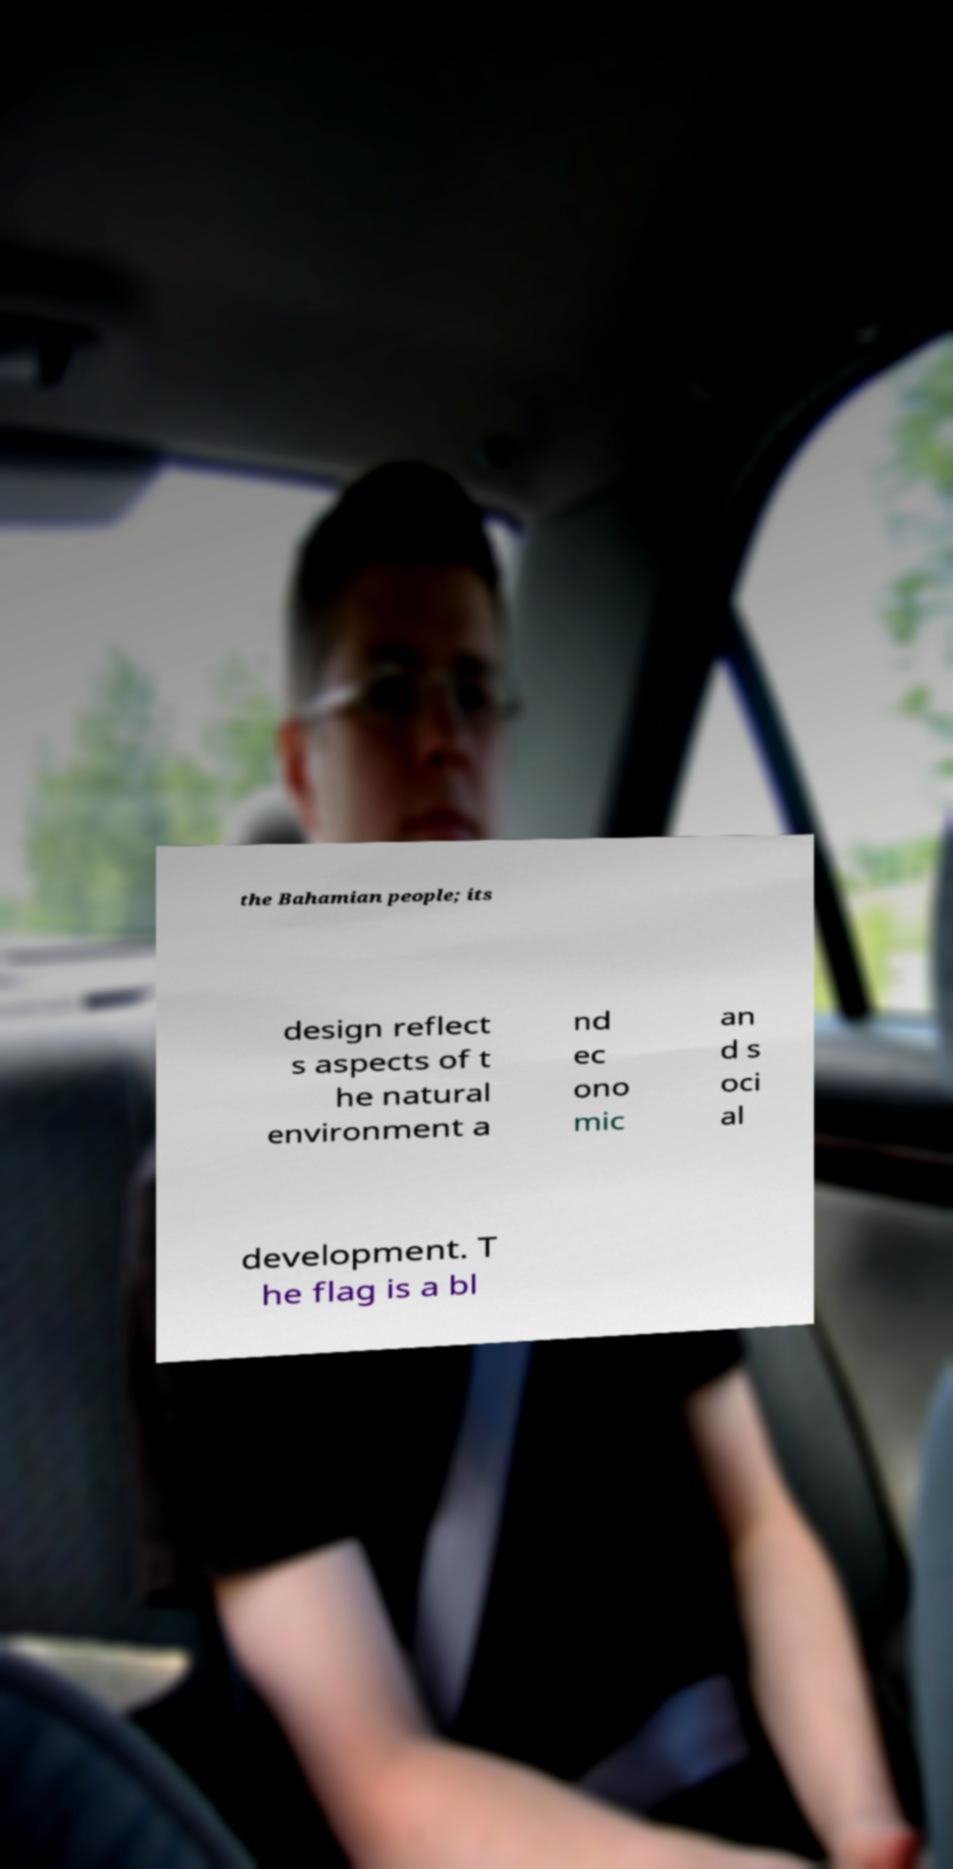Please read and relay the text visible in this image. What does it say? the Bahamian people; its design reflect s aspects of t he natural environment a nd ec ono mic an d s oci al development. T he flag is a bl 